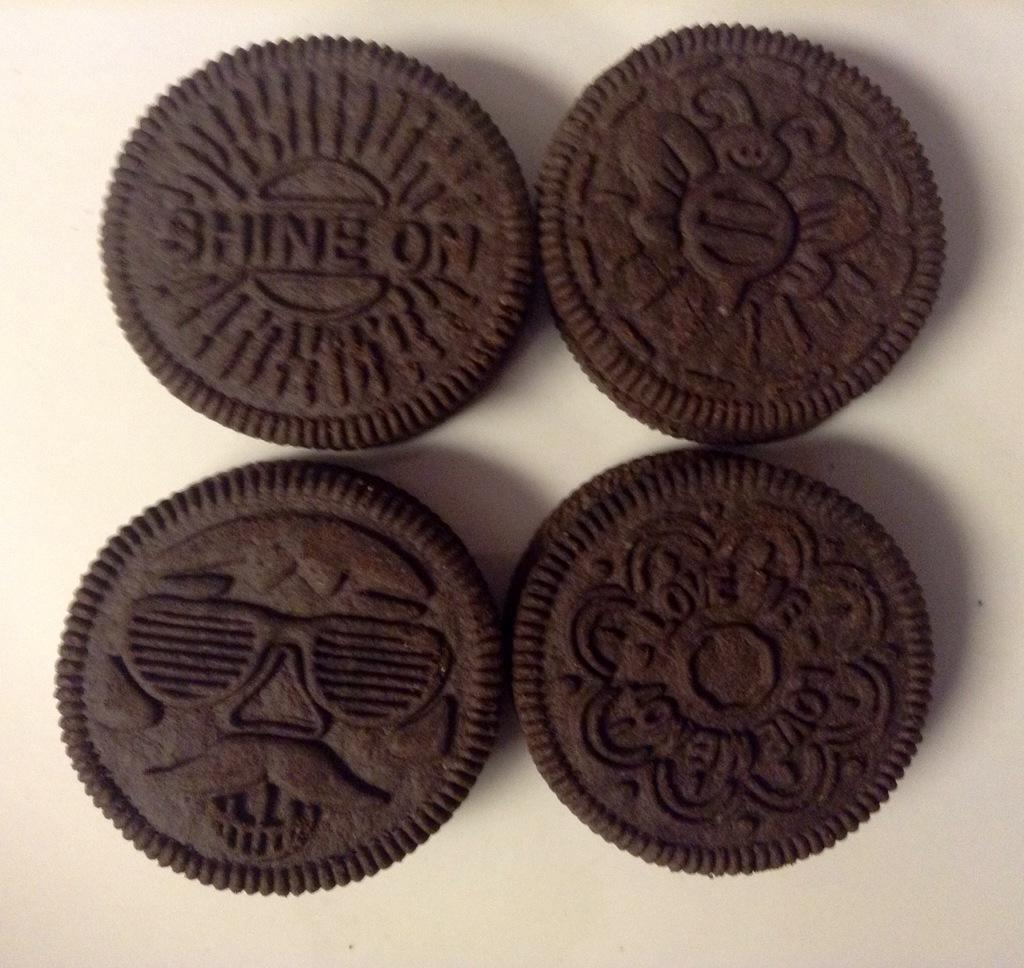What type of food is present in the image? There are four chocolate biscuits in the image. Where are the biscuits located in the image? The biscuits are in the middle of the image. What type of art is the judge creating with their fang in the image? There is no judge, art, or fang present in the image; it only features four chocolate biscuits. 